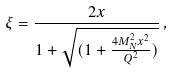Convert formula to latex. <formula><loc_0><loc_0><loc_500><loc_500>\xi = \frac { 2 x } { 1 + \sqrt { ( 1 + \frac { 4 M _ { N } ^ { 2 } x ^ { 2 } } { Q ^ { 2 } } ) } } \, ,</formula> 